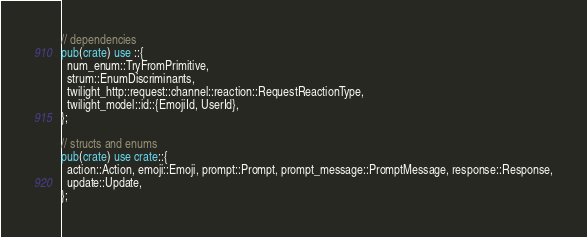Convert code to text. <code><loc_0><loc_0><loc_500><loc_500><_Rust_>// dependencies
pub(crate) use ::{
  num_enum::TryFromPrimitive,
  strum::EnumDiscriminants,
  twilight_http::request::channel::reaction::RequestReactionType,
  twilight_model::id::{EmojiId, UserId},
};

// structs and enums
pub(crate) use crate::{
  action::Action, emoji::Emoji, prompt::Prompt, prompt_message::PromptMessage, response::Response,
  update::Update,
};
</code> 